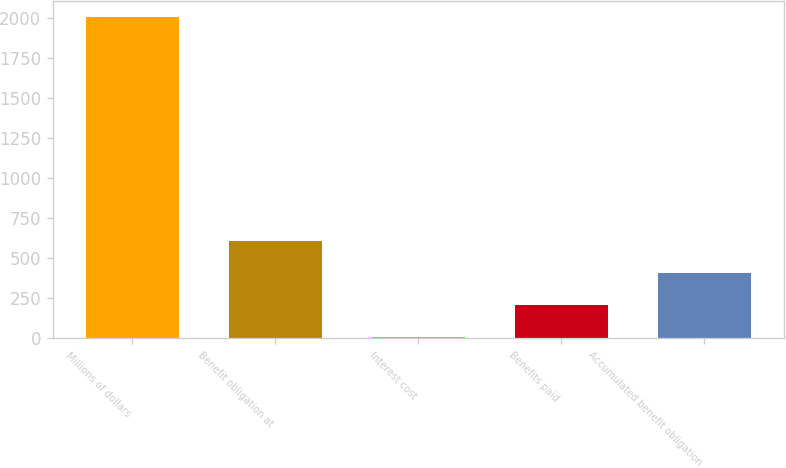Convert chart. <chart><loc_0><loc_0><loc_500><loc_500><bar_chart><fcel>Millions of dollars<fcel>Benefit obligation at<fcel>Interest cost<fcel>Benefits paid<fcel>Accumulated benefit obligation<nl><fcel>2007<fcel>607<fcel>7<fcel>207<fcel>407<nl></chart> 